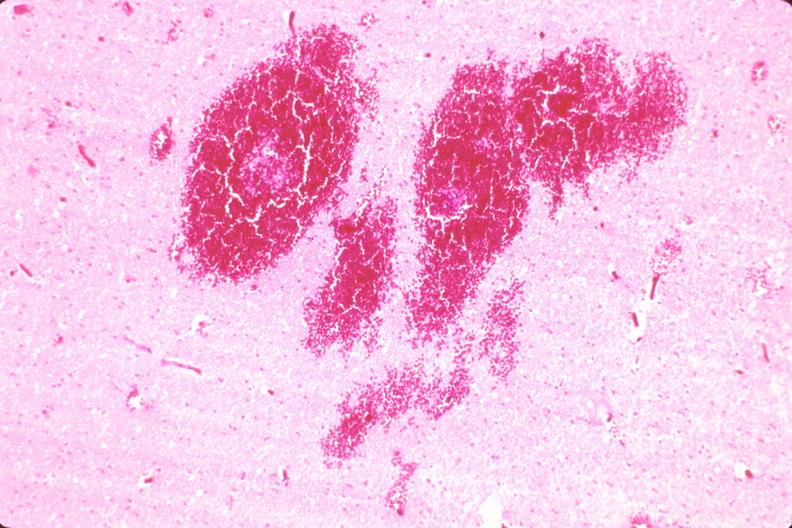why does this image show brain, infarct and hemorrhage?
Answer the question using a single word or phrase. Due to ruptured saccular aneurysm thrombosis of right middle cerebral artery 